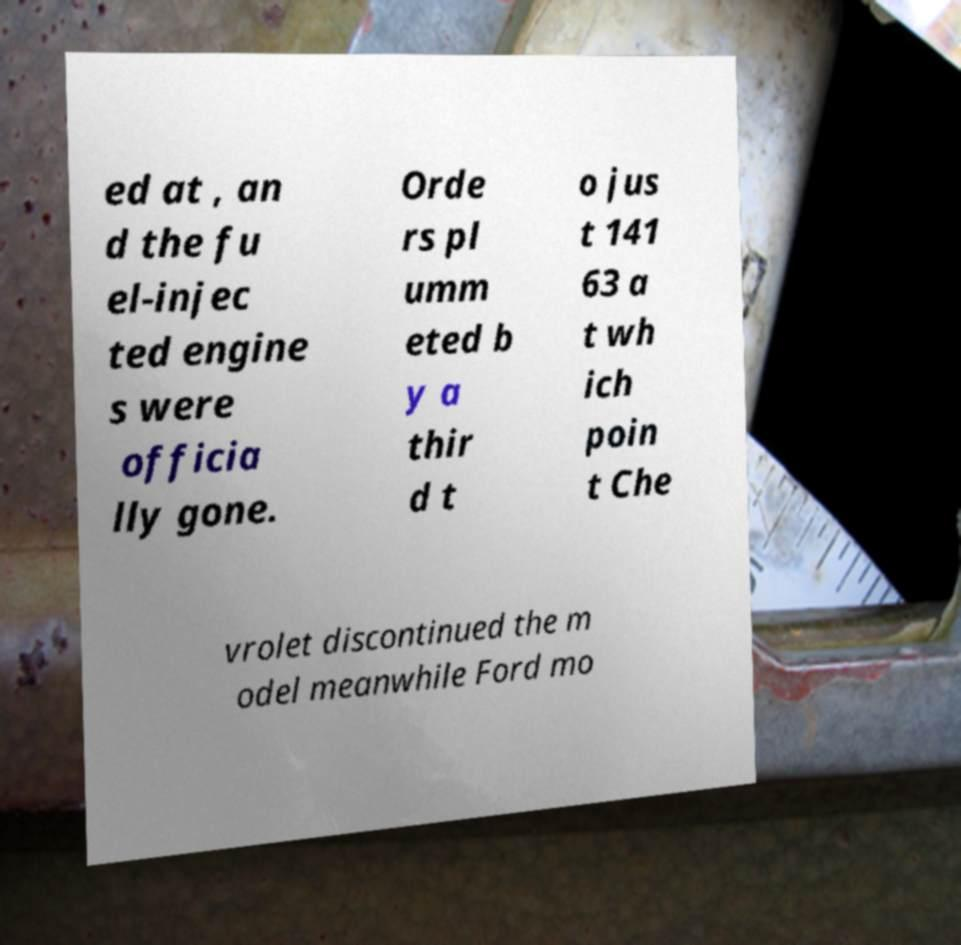Can you read and provide the text displayed in the image?This photo seems to have some interesting text. Can you extract and type it out for me? ed at , an d the fu el-injec ted engine s were officia lly gone. Orde rs pl umm eted b y a thir d t o jus t 141 63 a t wh ich poin t Che vrolet discontinued the m odel meanwhile Ford mo 